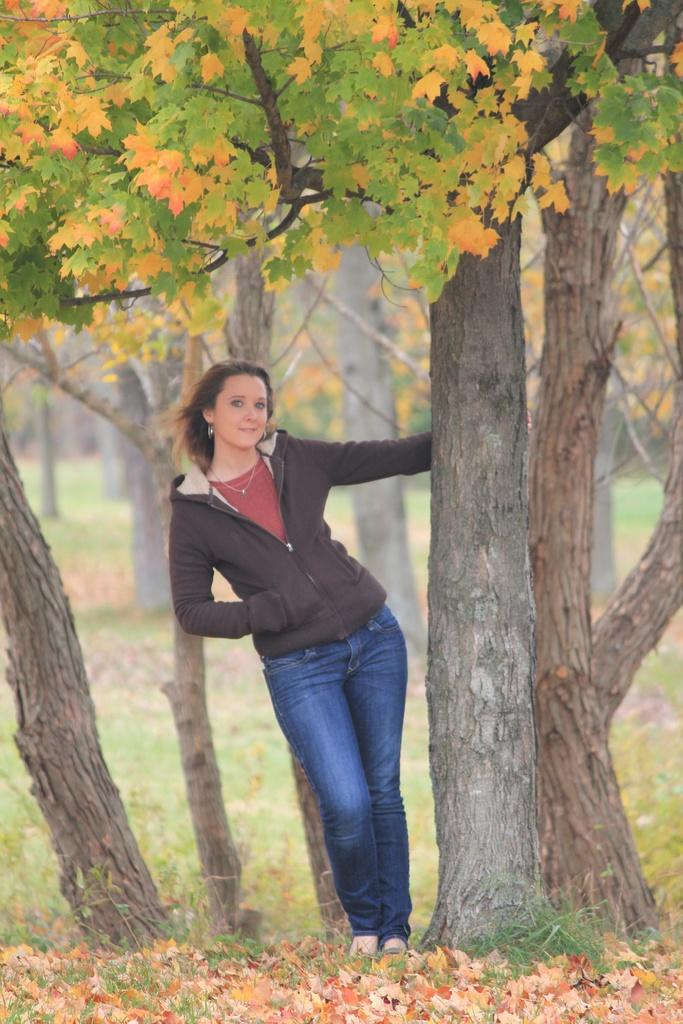What type of vegetation can be seen in the image? There are trees and grass visible in the image. What else can be seen in the image besides vegetation? There are leaves and a woman visible in the image. What is the woman wearing in the image? The woman is wearing a black color jacket. Can you tell me how many jars of pickles are visible in the image? There are no jars of pickles present in the image. What type of shoes is the woman wearing in the image? There is no information about the woman's shoes in the image. 